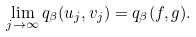<formula> <loc_0><loc_0><loc_500><loc_500>\lim _ { j \rightarrow \infty } q _ { \beta } ( u _ { j } , v _ { j } ) = q _ { \beta } ( f , g ) .</formula> 